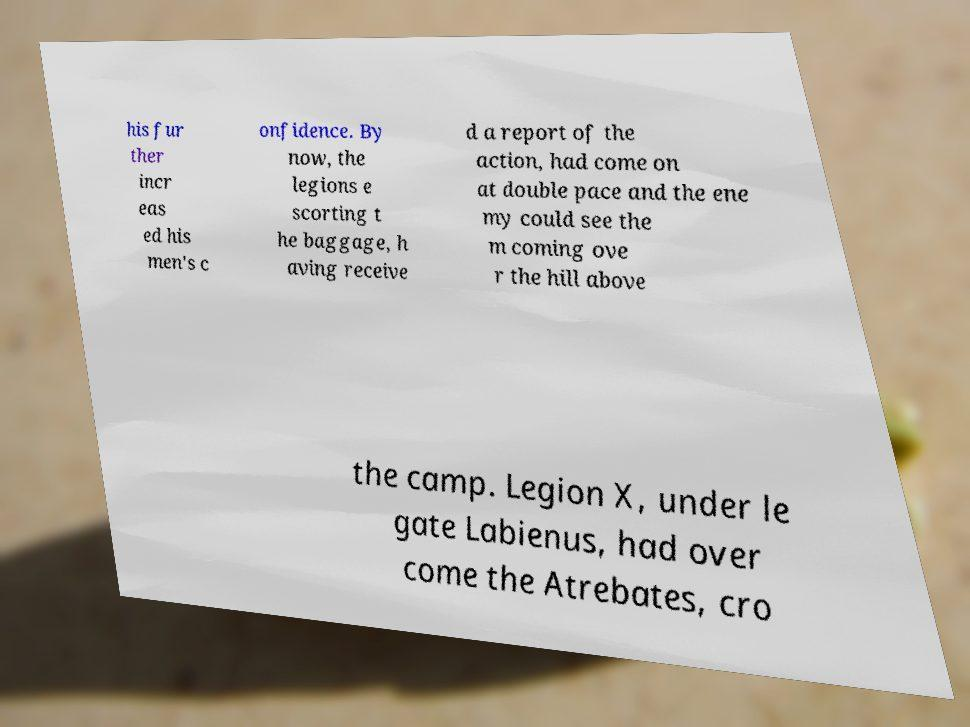Can you read and provide the text displayed in the image?This photo seems to have some interesting text. Can you extract and type it out for me? his fur ther incr eas ed his men's c onfidence. By now, the legions e scorting t he baggage, h aving receive d a report of the action, had come on at double pace and the ene my could see the m coming ove r the hill above the camp. Legion X, under le gate Labienus, had over come the Atrebates, cro 